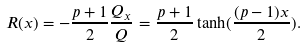Convert formula to latex. <formula><loc_0><loc_0><loc_500><loc_500>R ( x ) = - \frac { p + 1 } 2 \frac { Q _ { x } } Q = \frac { p + 1 } 2 \tanh ( \frac { ( p - 1 ) x } { 2 } ) .</formula> 